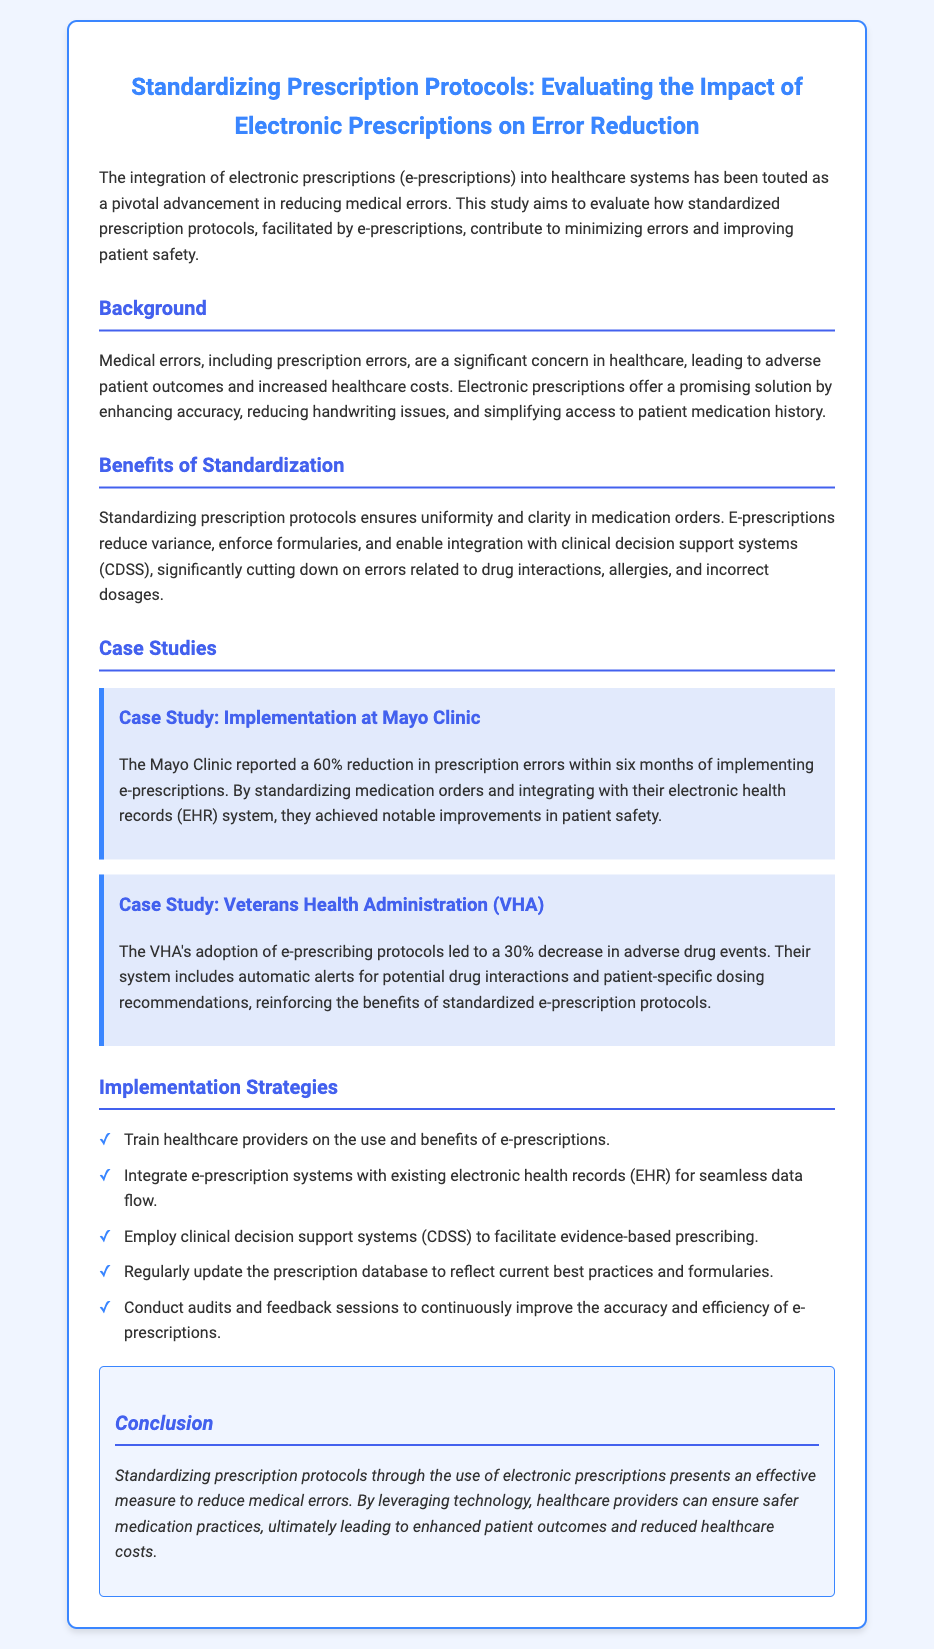What is the title of the document? The title of the document is presented in a prominent header format indicating the main focus of the content.
Answer: Standardizing Prescription Protocols: Evaluating the Impact of Electronic Prescriptions on Error Reduction What percentage of reduction in prescription errors was reported by the Mayo Clinic? This specific percentage indicates the effectiveness of e-prescriptions in a real-world case study and is mentioned clearly in the case section.
Answer: 60% What technology is emphasized as beneficial for reducing medical errors in prescription protocols? The document highlights a key technological advancement that aids in minimizing errors.
Answer: Electronic prescriptions What organization reported a 30% decrease in adverse drug events? This organization is specifically noted in the document for its successful implementation of e-prescribing protocols.
Answer: Veterans Health Administration Which support system is recommended for evidence-based prescribing? The document refers to a specific type of support system that assists healthcare providers in making informed prescribing decisions.
Answer: Clinical decision support systems What is one strategy for implementing e-prescription systems? This inquiry seeks specific implementation strategies mentioned in the document that contribute to better prescribing practices.
Answer: Train healthcare providers on the use and benefits of e-prescriptions What was the notable outcome of standardizing medication orders at the Mayo Clinic? The document indicates a specific outcome that highlights the benefits of process improvement following e-prescription adoption.
Answer: Improvements in patient safety What do e-prescriptions help reduce that is related to handwriting? This question addresses a particular issue associated with traditional prescriptions that e-prescriptions are designed to alleviate.
Answer: Handwriting issues In what year is the data about e-prescription impact being evaluated up to? While the document doesn't specify an exact year, it suggests currency in research and data context.
Answer: 2023 